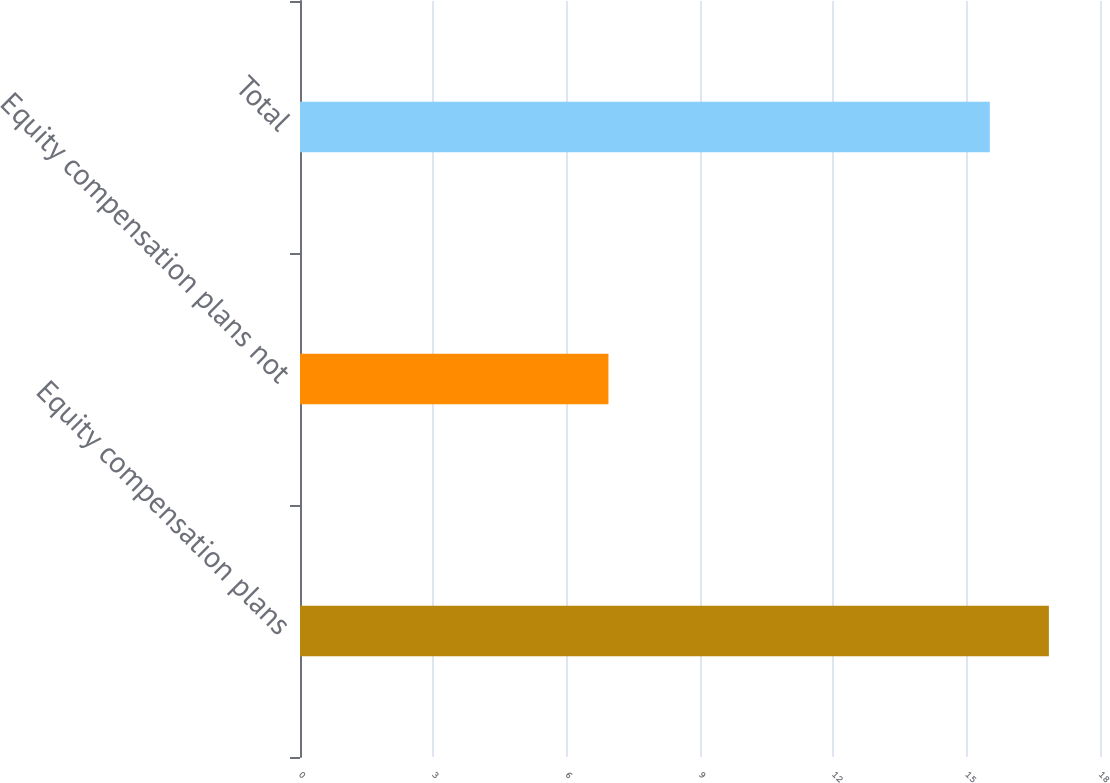Convert chart. <chart><loc_0><loc_0><loc_500><loc_500><bar_chart><fcel>Equity compensation plans<fcel>Equity compensation plans not<fcel>Total<nl><fcel>16.85<fcel>6.94<fcel>15.52<nl></chart> 